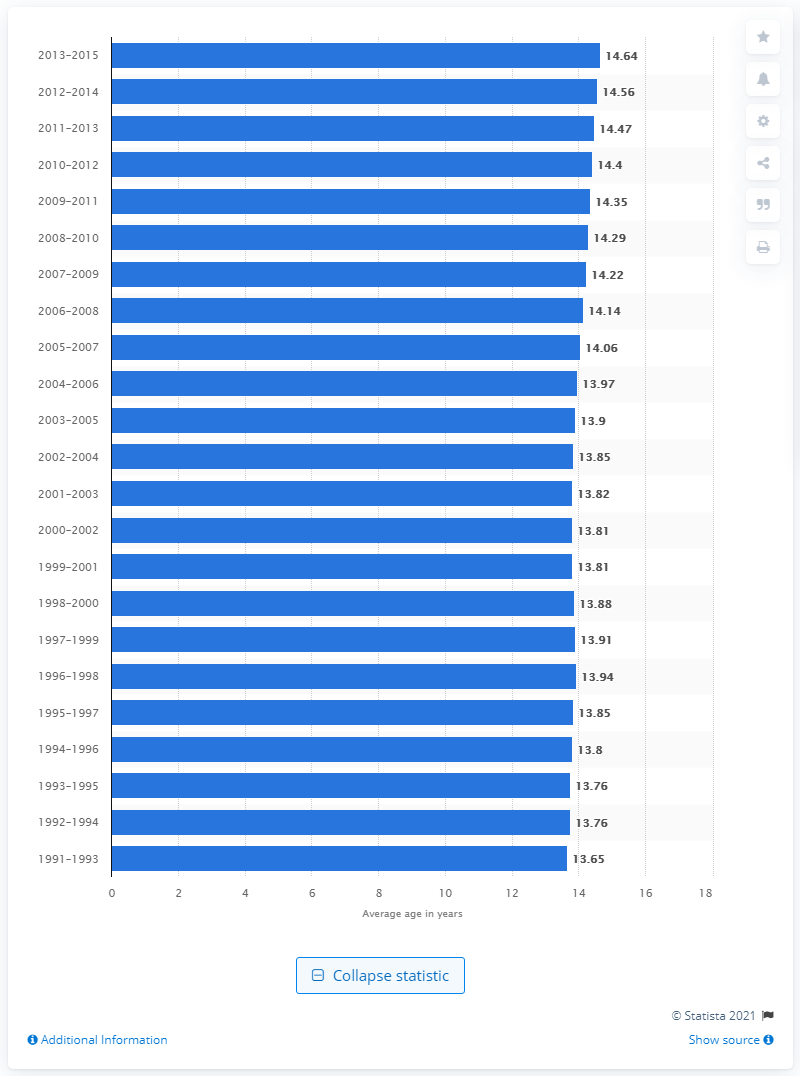Identify some key points in this picture. The average age of 12 to 20 years when they first drank alcohol was 14.64 years. 